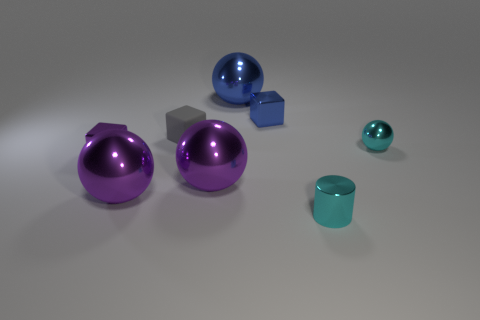Subtract 1 spheres. How many spheres are left? 3 Subtract all blue metallic spheres. How many spheres are left? 3 Subtract all cyan balls. How many balls are left? 3 Add 1 small rubber cubes. How many objects exist? 9 Subtract all green balls. Subtract all green cubes. How many balls are left? 4 Subtract all blocks. How many objects are left? 5 Subtract 0 purple cylinders. How many objects are left? 8 Subtract all large cyan objects. Subtract all spheres. How many objects are left? 4 Add 7 large metal balls. How many large metal balls are left? 10 Add 6 large purple shiny things. How many large purple shiny things exist? 8 